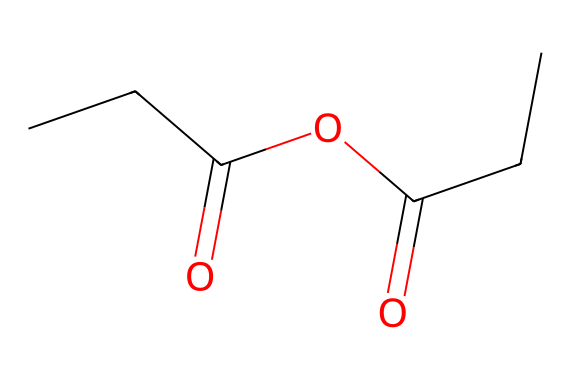What is the molecular formula of propionic anhydride? To determine the molecular formula from the SMILES representation CCC(=O)OC(=O)CC, identify the atoms present: there are 5 carbon (C) atoms, 8 hydrogen (H) atoms, and 4 oxygen (O) atoms. Consequently, the molecular formula is C5H8O4.
Answer: C5H8O4 How many carbon atoms are in propionic anhydride? Analyzing the SMILES CCC(=O)OC(=O)CC, count the 'C' characters: there are 5 carbon atoms in total, which can be grouped in the main chain and the carbonyl groups.
Answer: 5 What type of functional groups are present in propionic anhydride? From the SMILES representation, identify the groups: the molecule contains two acyl groups (from the carbonyls) and an ether functional group (from –O– linking the carbonyls). The presence of these groups indicates acyl and ether functionalities, respectively.
Answer: acyl and ether How many oxygen atoms are in propionic anhydride? By examining the SMILES notation CCC(=O)OC(=O)CC, count the 'O' characters: there are 4 oxygen atoms in the molecule, two from carbonyls and one from the ether.
Answer: 4 What is the primary type of reaction that yields propionic anhydride? Propionic anhydride is typically formed through the dehydration reaction between two molecules of propionic acid. In this process, a water molecule is eliminated, resulting in the formation of the anhydride.
Answer: dehydration reaction Is propionic anhydride a saturated or unsaturated compound? Based on the structure derived from the SMILES, the molecule does not contain any double bonds, and all carbon atoms are single-bonded in a chain with functional groups, indicating that it is saturated.
Answer: saturated What is the primary application of propionic anhydride? Propionic anhydride is primarily utilized in the synthesis of cellulose acetate propionate, which is a derivative used in the manufacturing of plastics and coatings.
Answer: cellulose acetate propionate 